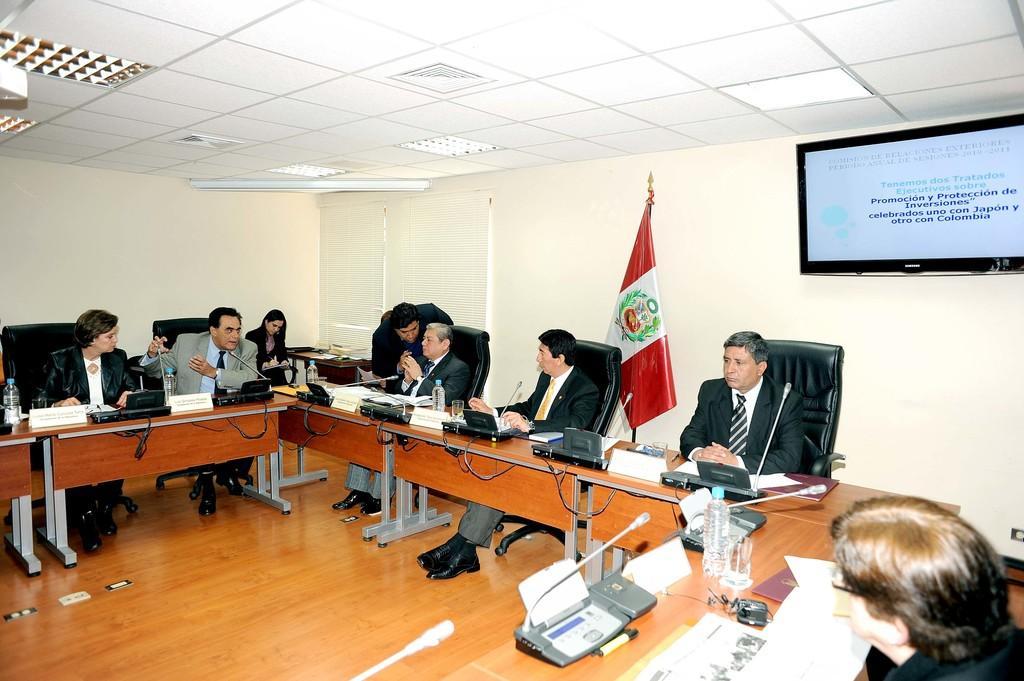Can you describe this image briefly? Here we can see a few people who are sitting on a chair and discussing about something. This is a television which is fixed to a wall and this is a flag. 